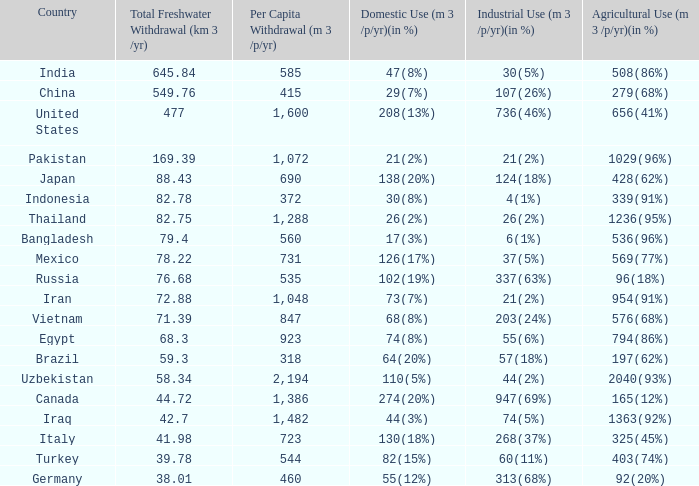75, and agricultural consumption (m3/p/yr)(in %) is 1363(92%)? 74(5%). 